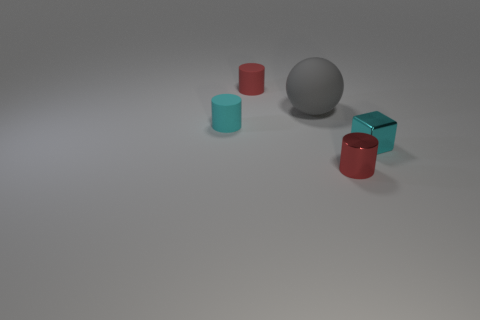Add 2 tiny cyan balls. How many objects exist? 7 Subtract all cubes. How many objects are left? 4 Add 4 purple cubes. How many purple cubes exist? 4 Subtract 0 blue spheres. How many objects are left? 5 Subtract all gray things. Subtract all gray matte spheres. How many objects are left? 3 Add 1 small cyan rubber cylinders. How many small cyan rubber cylinders are left? 2 